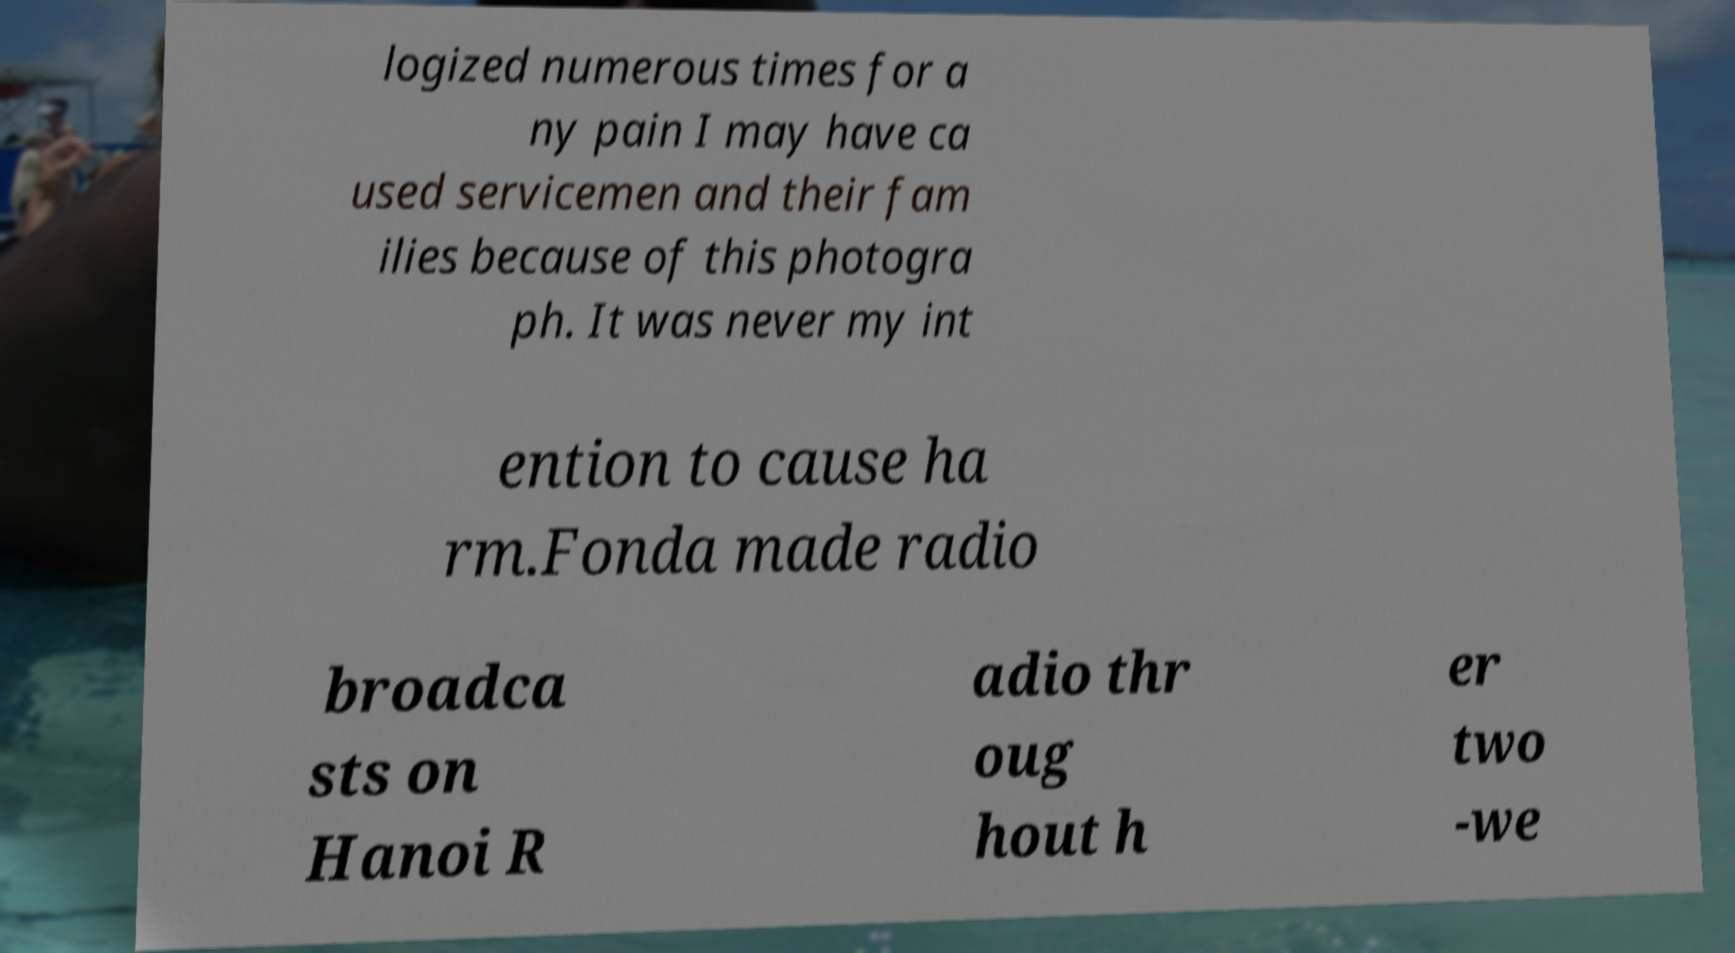Could you assist in decoding the text presented in this image and type it out clearly? logized numerous times for a ny pain I may have ca used servicemen and their fam ilies because of this photogra ph. It was never my int ention to cause ha rm.Fonda made radio broadca sts on Hanoi R adio thr oug hout h er two -we 